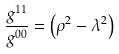<formula> <loc_0><loc_0><loc_500><loc_500>\frac { g ^ { 1 1 } } { g ^ { 0 0 } } = \left ( \rho ^ { 2 } - \lambda ^ { 2 } \right )</formula> 